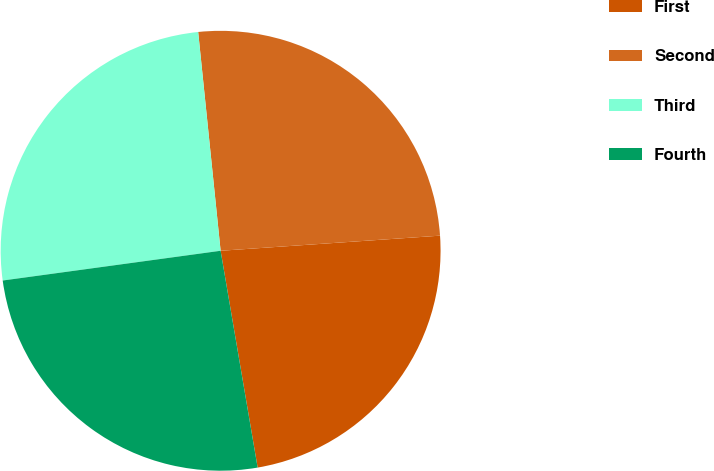Convert chart. <chart><loc_0><loc_0><loc_500><loc_500><pie_chart><fcel>First<fcel>Second<fcel>Third<fcel>Fourth<nl><fcel>23.4%<fcel>25.53%<fcel>25.53%<fcel>25.53%<nl></chart> 